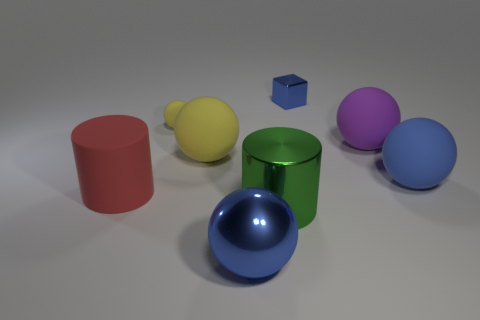Subtract 2 spheres. How many spheres are left? 3 Subtract all tiny matte balls. How many balls are left? 4 Subtract all purple spheres. How many spheres are left? 4 Subtract all cyan spheres. Subtract all yellow cylinders. How many spheres are left? 5 Add 1 large red rubber things. How many objects exist? 9 Subtract all cubes. How many objects are left? 7 Add 6 tiny brown objects. How many tiny brown objects exist? 6 Subtract 0 blue cylinders. How many objects are left? 8 Subtract all cyan metal blocks. Subtract all small blocks. How many objects are left? 7 Add 3 blue matte balls. How many blue matte balls are left? 4 